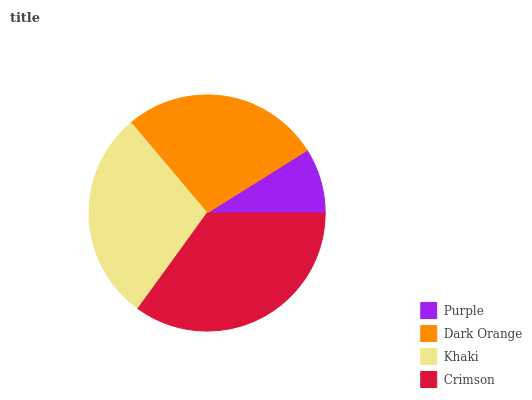Is Purple the minimum?
Answer yes or no. Yes. Is Crimson the maximum?
Answer yes or no. Yes. Is Dark Orange the minimum?
Answer yes or no. No. Is Dark Orange the maximum?
Answer yes or no. No. Is Dark Orange greater than Purple?
Answer yes or no. Yes. Is Purple less than Dark Orange?
Answer yes or no. Yes. Is Purple greater than Dark Orange?
Answer yes or no. No. Is Dark Orange less than Purple?
Answer yes or no. No. Is Khaki the high median?
Answer yes or no. Yes. Is Dark Orange the low median?
Answer yes or no. Yes. Is Crimson the high median?
Answer yes or no. No. Is Crimson the low median?
Answer yes or no. No. 